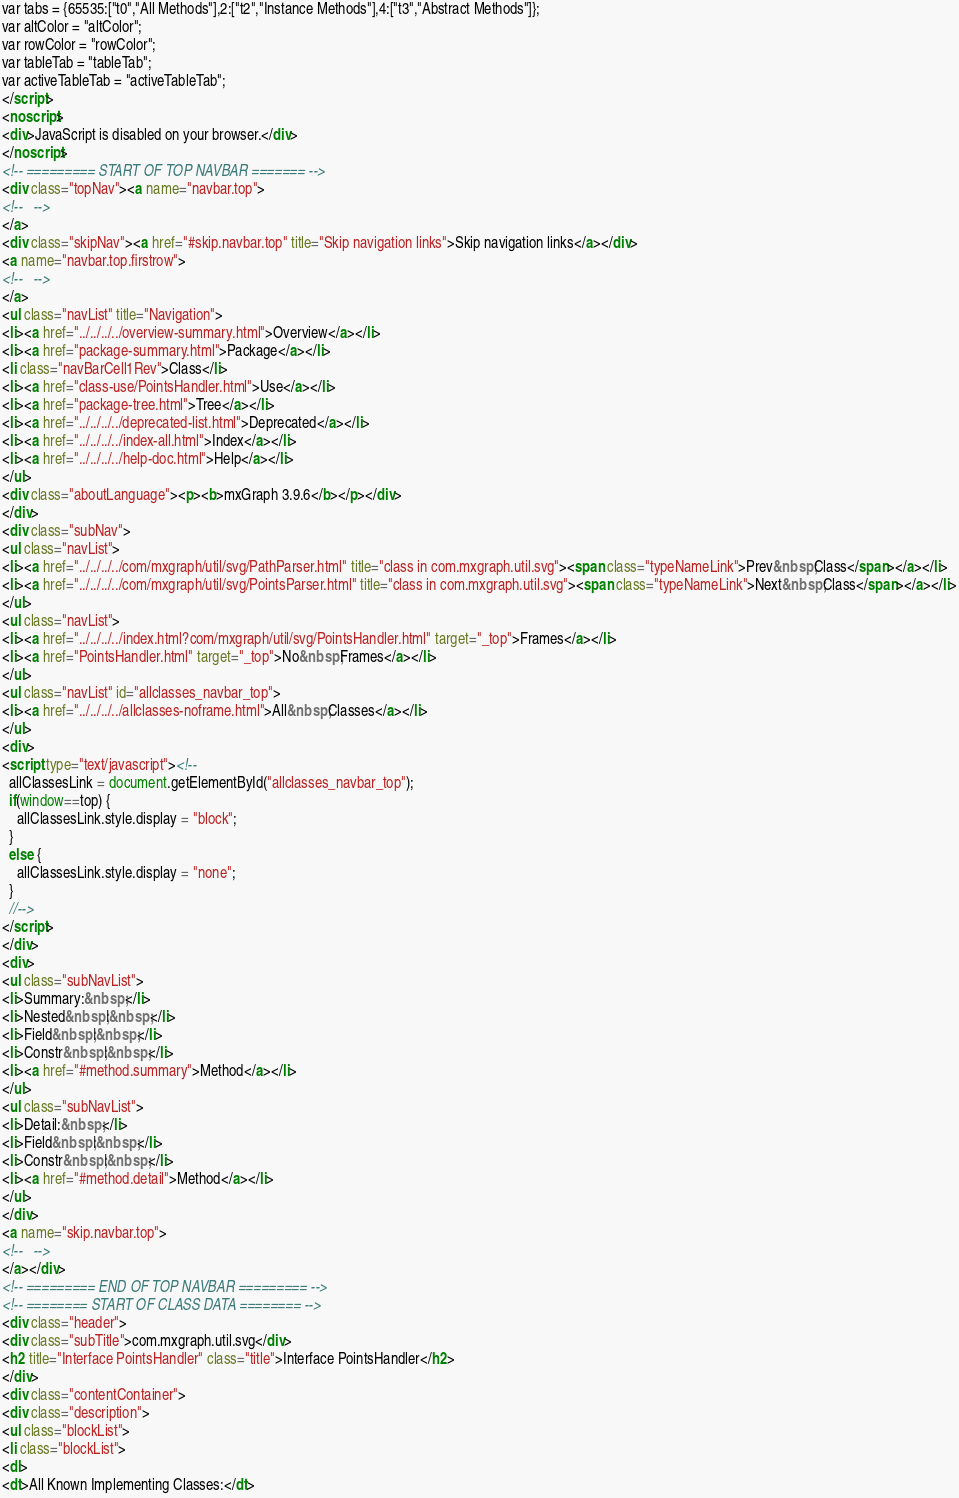<code> <loc_0><loc_0><loc_500><loc_500><_HTML_>var tabs = {65535:["t0","All Methods"],2:["t2","Instance Methods"],4:["t3","Abstract Methods"]};
var altColor = "altColor";
var rowColor = "rowColor";
var tableTab = "tableTab";
var activeTableTab = "activeTableTab";
</script>
<noscript>
<div>JavaScript is disabled on your browser.</div>
</noscript>
<!-- ========= START OF TOP NAVBAR ======= -->
<div class="topNav"><a name="navbar.top">
<!--   -->
</a>
<div class="skipNav"><a href="#skip.navbar.top" title="Skip navigation links">Skip navigation links</a></div>
<a name="navbar.top.firstrow">
<!--   -->
</a>
<ul class="navList" title="Navigation">
<li><a href="../../../../overview-summary.html">Overview</a></li>
<li><a href="package-summary.html">Package</a></li>
<li class="navBarCell1Rev">Class</li>
<li><a href="class-use/PointsHandler.html">Use</a></li>
<li><a href="package-tree.html">Tree</a></li>
<li><a href="../../../../deprecated-list.html">Deprecated</a></li>
<li><a href="../../../../index-all.html">Index</a></li>
<li><a href="../../../../help-doc.html">Help</a></li>
</ul>
<div class="aboutLanguage"><p><b>mxGraph 3.9.6</b></p></div>
</div>
<div class="subNav">
<ul class="navList">
<li><a href="../../../../com/mxgraph/util/svg/PathParser.html" title="class in com.mxgraph.util.svg"><span class="typeNameLink">Prev&nbsp;Class</span></a></li>
<li><a href="../../../../com/mxgraph/util/svg/PointsParser.html" title="class in com.mxgraph.util.svg"><span class="typeNameLink">Next&nbsp;Class</span></a></li>
</ul>
<ul class="navList">
<li><a href="../../../../index.html?com/mxgraph/util/svg/PointsHandler.html" target="_top">Frames</a></li>
<li><a href="PointsHandler.html" target="_top">No&nbsp;Frames</a></li>
</ul>
<ul class="navList" id="allclasses_navbar_top">
<li><a href="../../../../allclasses-noframe.html">All&nbsp;Classes</a></li>
</ul>
<div>
<script type="text/javascript"><!--
  allClassesLink = document.getElementById("allclasses_navbar_top");
  if(window==top) {
    allClassesLink.style.display = "block";
  }
  else {
    allClassesLink.style.display = "none";
  }
  //-->
</script>
</div>
<div>
<ul class="subNavList">
<li>Summary:&nbsp;</li>
<li>Nested&nbsp;|&nbsp;</li>
<li>Field&nbsp;|&nbsp;</li>
<li>Constr&nbsp;|&nbsp;</li>
<li><a href="#method.summary">Method</a></li>
</ul>
<ul class="subNavList">
<li>Detail:&nbsp;</li>
<li>Field&nbsp;|&nbsp;</li>
<li>Constr&nbsp;|&nbsp;</li>
<li><a href="#method.detail">Method</a></li>
</ul>
</div>
<a name="skip.navbar.top">
<!--   -->
</a></div>
<!-- ========= END OF TOP NAVBAR ========= -->
<!-- ======== START OF CLASS DATA ======== -->
<div class="header">
<div class="subTitle">com.mxgraph.util.svg</div>
<h2 title="Interface PointsHandler" class="title">Interface PointsHandler</h2>
</div>
<div class="contentContainer">
<div class="description">
<ul class="blockList">
<li class="blockList">
<dl>
<dt>All Known Implementing Classes:</dt></code> 